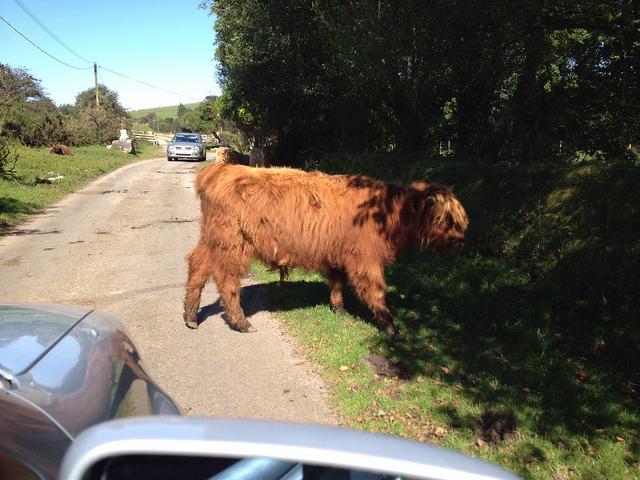What is the road made out of?
Be succinct. Gravel. Is this a city street?
Concise answer only. No. Is this likely a foreign country?
Quick response, please. Yes. 